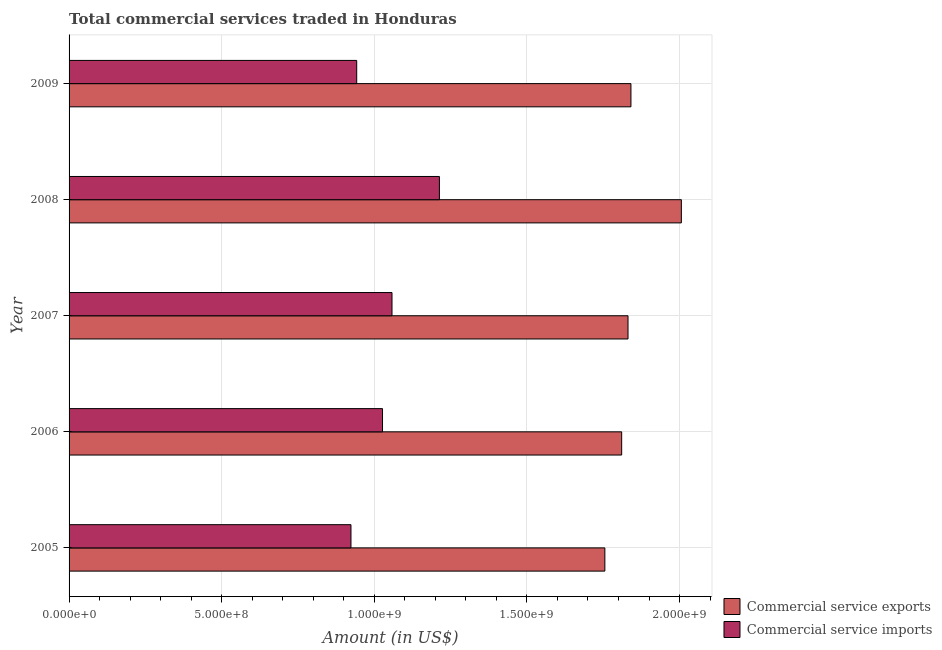Are the number of bars per tick equal to the number of legend labels?
Offer a terse response. Yes. How many bars are there on the 5th tick from the top?
Offer a very short reply. 2. What is the amount of commercial service imports in 2005?
Provide a succinct answer. 9.24e+08. Across all years, what is the maximum amount of commercial service imports?
Your answer should be compact. 1.21e+09. Across all years, what is the minimum amount of commercial service exports?
Offer a terse response. 1.76e+09. In which year was the amount of commercial service exports maximum?
Offer a terse response. 2008. In which year was the amount of commercial service exports minimum?
Your response must be concise. 2005. What is the total amount of commercial service exports in the graph?
Offer a terse response. 9.24e+09. What is the difference between the amount of commercial service exports in 2006 and that in 2007?
Make the answer very short. -2.07e+07. What is the difference between the amount of commercial service exports in 2007 and the amount of commercial service imports in 2005?
Provide a succinct answer. 9.08e+08. What is the average amount of commercial service exports per year?
Ensure brevity in your answer.  1.85e+09. In the year 2005, what is the difference between the amount of commercial service exports and amount of commercial service imports?
Your answer should be very brief. 8.32e+08. In how many years, is the amount of commercial service imports greater than 800000000 US$?
Your answer should be compact. 5. What is the ratio of the amount of commercial service imports in 2007 to that in 2008?
Offer a very short reply. 0.87. Is the amount of commercial service exports in 2007 less than that in 2009?
Keep it short and to the point. Yes. What is the difference between the highest and the second highest amount of commercial service exports?
Provide a succinct answer. 1.65e+08. What is the difference between the highest and the lowest amount of commercial service exports?
Provide a short and direct response. 2.51e+08. What does the 2nd bar from the top in 2007 represents?
Provide a succinct answer. Commercial service exports. What does the 1st bar from the bottom in 2009 represents?
Ensure brevity in your answer.  Commercial service exports. How many years are there in the graph?
Your response must be concise. 5. Does the graph contain any zero values?
Your answer should be very brief. No. Where does the legend appear in the graph?
Offer a very short reply. Bottom right. How are the legend labels stacked?
Your response must be concise. Vertical. What is the title of the graph?
Your answer should be very brief. Total commercial services traded in Honduras. Does "IMF nonconcessional" appear as one of the legend labels in the graph?
Provide a short and direct response. No. What is the label or title of the Y-axis?
Ensure brevity in your answer.  Year. What is the Amount (in US$) of Commercial service exports in 2005?
Your response must be concise. 1.76e+09. What is the Amount (in US$) of Commercial service imports in 2005?
Provide a succinct answer. 9.24e+08. What is the Amount (in US$) of Commercial service exports in 2006?
Provide a short and direct response. 1.81e+09. What is the Amount (in US$) of Commercial service imports in 2006?
Offer a very short reply. 1.03e+09. What is the Amount (in US$) of Commercial service exports in 2007?
Your answer should be compact. 1.83e+09. What is the Amount (in US$) of Commercial service imports in 2007?
Provide a succinct answer. 1.06e+09. What is the Amount (in US$) of Commercial service exports in 2008?
Offer a terse response. 2.01e+09. What is the Amount (in US$) in Commercial service imports in 2008?
Keep it short and to the point. 1.21e+09. What is the Amount (in US$) in Commercial service exports in 2009?
Keep it short and to the point. 1.84e+09. What is the Amount (in US$) of Commercial service imports in 2009?
Give a very brief answer. 9.42e+08. Across all years, what is the maximum Amount (in US$) in Commercial service exports?
Provide a succinct answer. 2.01e+09. Across all years, what is the maximum Amount (in US$) of Commercial service imports?
Your response must be concise. 1.21e+09. Across all years, what is the minimum Amount (in US$) of Commercial service exports?
Provide a short and direct response. 1.76e+09. Across all years, what is the minimum Amount (in US$) of Commercial service imports?
Make the answer very short. 9.24e+08. What is the total Amount (in US$) in Commercial service exports in the graph?
Provide a short and direct response. 9.24e+09. What is the total Amount (in US$) in Commercial service imports in the graph?
Your answer should be compact. 5.16e+09. What is the difference between the Amount (in US$) in Commercial service exports in 2005 and that in 2006?
Give a very brief answer. -5.51e+07. What is the difference between the Amount (in US$) of Commercial service imports in 2005 and that in 2006?
Offer a very short reply. -1.03e+08. What is the difference between the Amount (in US$) in Commercial service exports in 2005 and that in 2007?
Offer a terse response. -7.58e+07. What is the difference between the Amount (in US$) in Commercial service imports in 2005 and that in 2007?
Give a very brief answer. -1.34e+08. What is the difference between the Amount (in US$) of Commercial service exports in 2005 and that in 2008?
Your answer should be very brief. -2.51e+08. What is the difference between the Amount (in US$) in Commercial service imports in 2005 and that in 2008?
Offer a very short reply. -2.90e+08. What is the difference between the Amount (in US$) of Commercial service exports in 2005 and that in 2009?
Offer a terse response. -8.54e+07. What is the difference between the Amount (in US$) of Commercial service imports in 2005 and that in 2009?
Ensure brevity in your answer.  -1.88e+07. What is the difference between the Amount (in US$) in Commercial service exports in 2006 and that in 2007?
Provide a succinct answer. -2.07e+07. What is the difference between the Amount (in US$) in Commercial service imports in 2006 and that in 2007?
Provide a succinct answer. -3.11e+07. What is the difference between the Amount (in US$) of Commercial service exports in 2006 and that in 2008?
Make the answer very short. -1.96e+08. What is the difference between the Amount (in US$) of Commercial service imports in 2006 and that in 2008?
Your answer should be very brief. -1.86e+08. What is the difference between the Amount (in US$) of Commercial service exports in 2006 and that in 2009?
Provide a short and direct response. -3.04e+07. What is the difference between the Amount (in US$) of Commercial service imports in 2006 and that in 2009?
Offer a terse response. 8.46e+07. What is the difference between the Amount (in US$) in Commercial service exports in 2007 and that in 2008?
Your answer should be compact. -1.75e+08. What is the difference between the Amount (in US$) in Commercial service imports in 2007 and that in 2008?
Your response must be concise. -1.55e+08. What is the difference between the Amount (in US$) of Commercial service exports in 2007 and that in 2009?
Keep it short and to the point. -9.61e+06. What is the difference between the Amount (in US$) in Commercial service imports in 2007 and that in 2009?
Offer a very short reply. 1.16e+08. What is the difference between the Amount (in US$) in Commercial service exports in 2008 and that in 2009?
Provide a succinct answer. 1.65e+08. What is the difference between the Amount (in US$) of Commercial service imports in 2008 and that in 2009?
Your answer should be compact. 2.71e+08. What is the difference between the Amount (in US$) in Commercial service exports in 2005 and the Amount (in US$) in Commercial service imports in 2006?
Keep it short and to the point. 7.28e+08. What is the difference between the Amount (in US$) in Commercial service exports in 2005 and the Amount (in US$) in Commercial service imports in 2007?
Your answer should be very brief. 6.97e+08. What is the difference between the Amount (in US$) in Commercial service exports in 2005 and the Amount (in US$) in Commercial service imports in 2008?
Offer a very short reply. 5.42e+08. What is the difference between the Amount (in US$) of Commercial service exports in 2005 and the Amount (in US$) of Commercial service imports in 2009?
Offer a very short reply. 8.13e+08. What is the difference between the Amount (in US$) of Commercial service exports in 2006 and the Amount (in US$) of Commercial service imports in 2007?
Offer a terse response. 7.52e+08. What is the difference between the Amount (in US$) in Commercial service exports in 2006 and the Amount (in US$) in Commercial service imports in 2008?
Offer a terse response. 5.97e+08. What is the difference between the Amount (in US$) in Commercial service exports in 2006 and the Amount (in US$) in Commercial service imports in 2009?
Make the answer very short. 8.68e+08. What is the difference between the Amount (in US$) in Commercial service exports in 2007 and the Amount (in US$) in Commercial service imports in 2008?
Offer a terse response. 6.18e+08. What is the difference between the Amount (in US$) in Commercial service exports in 2007 and the Amount (in US$) in Commercial service imports in 2009?
Keep it short and to the point. 8.89e+08. What is the difference between the Amount (in US$) in Commercial service exports in 2008 and the Amount (in US$) in Commercial service imports in 2009?
Give a very brief answer. 1.06e+09. What is the average Amount (in US$) of Commercial service exports per year?
Your answer should be compact. 1.85e+09. What is the average Amount (in US$) in Commercial service imports per year?
Provide a short and direct response. 1.03e+09. In the year 2005, what is the difference between the Amount (in US$) of Commercial service exports and Amount (in US$) of Commercial service imports?
Provide a succinct answer. 8.32e+08. In the year 2006, what is the difference between the Amount (in US$) of Commercial service exports and Amount (in US$) of Commercial service imports?
Your answer should be very brief. 7.84e+08. In the year 2007, what is the difference between the Amount (in US$) in Commercial service exports and Amount (in US$) in Commercial service imports?
Provide a short and direct response. 7.73e+08. In the year 2008, what is the difference between the Amount (in US$) of Commercial service exports and Amount (in US$) of Commercial service imports?
Provide a succinct answer. 7.93e+08. In the year 2009, what is the difference between the Amount (in US$) in Commercial service exports and Amount (in US$) in Commercial service imports?
Your answer should be very brief. 8.99e+08. What is the ratio of the Amount (in US$) of Commercial service exports in 2005 to that in 2006?
Provide a short and direct response. 0.97. What is the ratio of the Amount (in US$) in Commercial service imports in 2005 to that in 2006?
Keep it short and to the point. 0.9. What is the ratio of the Amount (in US$) of Commercial service exports in 2005 to that in 2007?
Provide a short and direct response. 0.96. What is the ratio of the Amount (in US$) of Commercial service imports in 2005 to that in 2007?
Your answer should be very brief. 0.87. What is the ratio of the Amount (in US$) of Commercial service exports in 2005 to that in 2008?
Ensure brevity in your answer.  0.88. What is the ratio of the Amount (in US$) in Commercial service imports in 2005 to that in 2008?
Provide a short and direct response. 0.76. What is the ratio of the Amount (in US$) in Commercial service exports in 2005 to that in 2009?
Offer a terse response. 0.95. What is the ratio of the Amount (in US$) of Commercial service imports in 2005 to that in 2009?
Ensure brevity in your answer.  0.98. What is the ratio of the Amount (in US$) in Commercial service exports in 2006 to that in 2007?
Give a very brief answer. 0.99. What is the ratio of the Amount (in US$) of Commercial service imports in 2006 to that in 2007?
Offer a terse response. 0.97. What is the ratio of the Amount (in US$) in Commercial service exports in 2006 to that in 2008?
Your response must be concise. 0.9. What is the ratio of the Amount (in US$) in Commercial service imports in 2006 to that in 2008?
Your response must be concise. 0.85. What is the ratio of the Amount (in US$) of Commercial service exports in 2006 to that in 2009?
Provide a short and direct response. 0.98. What is the ratio of the Amount (in US$) of Commercial service imports in 2006 to that in 2009?
Provide a short and direct response. 1.09. What is the ratio of the Amount (in US$) of Commercial service exports in 2007 to that in 2008?
Offer a very short reply. 0.91. What is the ratio of the Amount (in US$) of Commercial service imports in 2007 to that in 2008?
Ensure brevity in your answer.  0.87. What is the ratio of the Amount (in US$) of Commercial service imports in 2007 to that in 2009?
Make the answer very short. 1.12. What is the ratio of the Amount (in US$) in Commercial service exports in 2008 to that in 2009?
Give a very brief answer. 1.09. What is the ratio of the Amount (in US$) in Commercial service imports in 2008 to that in 2009?
Provide a short and direct response. 1.29. What is the difference between the highest and the second highest Amount (in US$) in Commercial service exports?
Ensure brevity in your answer.  1.65e+08. What is the difference between the highest and the second highest Amount (in US$) of Commercial service imports?
Your answer should be very brief. 1.55e+08. What is the difference between the highest and the lowest Amount (in US$) in Commercial service exports?
Offer a very short reply. 2.51e+08. What is the difference between the highest and the lowest Amount (in US$) in Commercial service imports?
Ensure brevity in your answer.  2.90e+08. 